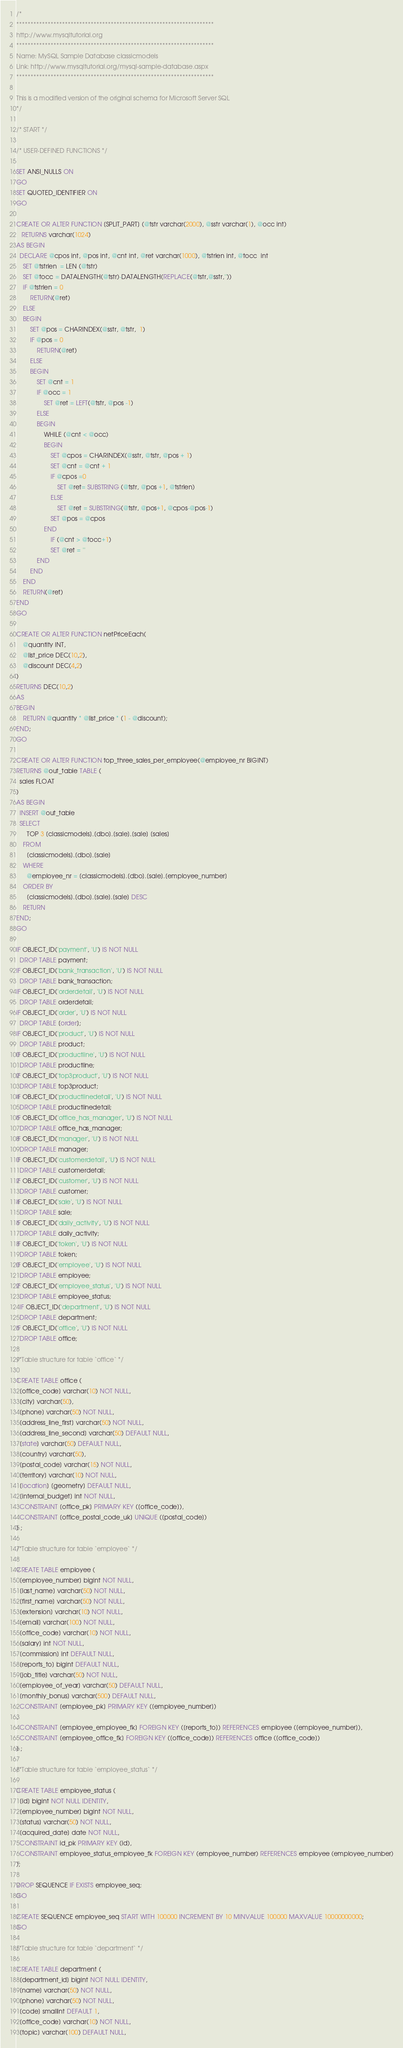Convert code to text. <code><loc_0><loc_0><loc_500><loc_500><_SQL_>/*
*********************************************************************
http://www.mysqltutorial.org
*********************************************************************
Name: MySQL Sample Database classicmodels
Link: http://www.mysqltutorial.org/mysql-sample-database.aspx
*********************************************************************

This is a modified version of the original schema for Microsoft Server SQL
*/

/* START */

/* USER-DEFINED FUNCTIONS */

SET ANSI_NULLS ON
GO
SET QUOTED_IDENTIFIER ON
GO

CREATE OR ALTER FUNCTION [SPLIT_PART] (@tstr varchar(2000), @sstr varchar(1), @occ int)
   RETURNS varchar(1024)
AS BEGIN
  DECLARE @cpos int, @pos int, @cnt int, @ret varchar(1000), @tstrlen int, @tocc  int
	SET @tstrlen  = LEN (@tstr)
	SET @tocc = DATALENGTH(@tstr)-DATALENGTH(REPLACE(@tstr,@sstr,''))
	iF @tstrlen = 0
		RETURN(@ret)
	ELSE
	BEGIN
		SET @pos = CHARINDEX(@sstr, @tstr,  1)
		IF @pos = 0
			RETURN(@ret)
		ELSE
		BEGIN
			SET @cnt = 1		
			IF @occ = 1 
				SET @ret = LEFT(@tstr, @pos -1) 
			ELSE
			BEGIN
				WHILE (@cnt < @occ)
				BEGIN
					SET @cpos = CHARINDEX(@sstr, @tstr, @pos + 1)
					SET @cnt = @cnt + 1
					IF @cpos =0
						SET @ret= SUBSTRING (@tstr, @pos +1, @tstrlen) 
					ELSE
						SET @ret = SUBSTRING(@tstr, @pos+1, @cpos-@pos-1)
					SET @pos = @cpos	
				END
					IF (@cnt > @tocc+1)
					SET @ret = ''
			END
		END
	END
	RETURN(@ret)
END
GO

CREATE OR ALTER FUNCTION netPriceEach(
    @quantity INT,
    @list_price DEC(10,2),
    @discount DEC(4,2)
)
RETURNS DEC(10,2)
AS 
BEGIN
    RETURN @quantity * @list_price * (1 - @discount);
END;
GO

CREATE OR ALTER FUNCTION top_three_sales_per_employee(@employee_nr BIGINT)
RETURNS @out_table TABLE (
  sales FLOAT
)
AS BEGIN
  INSERT @out_table
  SELECT 
      TOP 3 [classicmodels].[dbo].[sale].[sale] [sales] 
    FROM 
      [classicmodels].[dbo].[sale] 
    WHERE 
      @employee_nr = [classicmodels].[dbo].[sale].[employee_number] 
    ORDER BY 
      [classicmodels].[dbo].[sale].[sale] DESC
    RETURN
END;	
GO

IF OBJECT_ID('payment', 'U') IS NOT NULL 
  DROP TABLE payment;  
IF OBJECT_ID('bank_transaction', 'U') IS NOT NULL 
  DROP TABLE bank_transaction;  
IF OBJECT_ID('orderdetail', 'U') IS NOT NULL 
  DROP TABLE orderdetail;
IF OBJECT_ID('order', 'U') IS NOT NULL 
  DROP TABLE [order];
IF OBJECT_ID('product', 'U') IS NOT NULL 
  DROP TABLE product;
IF OBJECT_ID('productline', 'U') IS NOT NULL 
  DROP TABLE productline;
IF OBJECT_ID('top3product', 'U') IS NOT NULL 
  DROP TABLE top3product;
IF OBJECT_ID('productlinedetail', 'U') IS NOT NULL 
  DROP TABLE productlinedetail;
IF OBJECT_ID('office_has_manager', 'U') IS NOT NULL 
  DROP TABLE office_has_manager;
IF OBJECT_ID('manager', 'U') IS NOT NULL 
  DROP TABLE manager;
IF OBJECT_ID('customerdetail', 'U') IS NOT NULL 
  DROP TABLE customerdetail;
IF OBJECT_ID('customer', 'U') IS NOT NULL 
  DROP TABLE customer;
IF OBJECT_ID('sale', 'U') IS NOT NULL 
  DROP TABLE sale;
IF OBJECT_ID('daily_activity', 'U') IS NOT NULL 
  DROP TABLE daily_activity;
IF OBJECT_ID('token', 'U') IS NOT NULL 
  DROP TABLE token;
IF OBJECT_ID('employee', 'U') IS NOT NULL 
  DROP TABLE employee;
IF OBJECT_ID('employee_status', 'U') IS NOT NULL 
  DROP TABLE employee_status;
  IF OBJECT_ID('department', 'U') IS NOT NULL 
  DROP TABLE department;
IF OBJECT_ID('office', 'U') IS NOT NULL 
  DROP TABLE office;

/*Table structure for table `office` */

CREATE TABLE office (
  [office_code] varchar(10) NOT NULL,
  [city] varchar(50),
  [phone] varchar(50) NOT NULL,
  [address_line_first] varchar(50) NOT NULL,
  [address_line_second] varchar(50) DEFAULT NULL,
  [state] varchar(50) DEFAULT NULL,
  [country] varchar(50),
  [postal_code] varchar(15) NOT NULL,
  [territory] varchar(10) NOT NULL,
  [location] [geometry] DEFAULT NULL,
  [internal_budget] int NOT NULL,
  CONSTRAINT [office_pk] PRIMARY KEY ([office_code]),
  CONSTRAINT [office_postal_code_uk] UNIQUE ([postal_code])
) ;

/*Table structure for table `employee` */

CREATE TABLE employee (
  [employee_number] bigint NOT NULL,
  [last_name] varchar(50) NOT NULL,
  [first_name] varchar(50) NOT NULL,
  [extension] varchar(10) NOT NULL,
  [email] varchar(100) NOT NULL,
  [office_code] varchar(10) NOT NULL,
  [salary] int NOT NULL,
  [commission] int DEFAULT NULL,
  [reports_to] bigint DEFAULT NULL,
  [job_title] varchar(50) NOT NULL,
  [employee_of_year] varchar(50) DEFAULT NULL,
  [monthly_bonus] varchar(500) DEFAULT NULL,
  CONSTRAINT [employee_pk] PRIMARY KEY ([employee_number])
,
  CONSTRAINT [employee_employee_fk] FOREIGN KEY ([reports_to]) REFERENCES employee ([employee_number]),
  CONSTRAINT [employee_office_fk] FOREIGN KEY ([office_code]) REFERENCES office ([office_code])
) ;

/*Table structure for table `employee_status` */

CREATE TABLE employee_status (
  [id] bigint NOT NULL IDENTITY,
  [employee_number] bigint NOT NULL,  
  [status] varchar(50) NOT NULL,  
  [acquired_date] date NOT NULL,
  CONSTRAINT id_pk PRIMARY KEY (id),  
  CONSTRAINT employee_status_employee_fk FOREIGN KEY (employee_number) REFERENCES employee (employee_number)
);

DROP SEQUENCE IF EXISTS employee_seq;
GO

CREATE SEQUENCE employee_seq START WITH 100000 INCREMENT BY 10 MINVALUE 100000 MAXVALUE 10000000000;
GO

/*Table structure for table `department` */

CREATE TABLE department (
  [department_id] bigint NOT NULL IDENTITY,  
  [name] varchar(50) NOT NULL,
  [phone] varchar(50) NOT NULL,
  [code] smallint DEFAULT 1,
  [office_code] varchar(10) NOT NULL,
  [topic] varchar(100) DEFAULT NULL,  </code> 